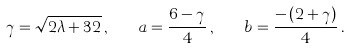<formula> <loc_0><loc_0><loc_500><loc_500>\gamma = \sqrt { 2 \lambda + 3 2 } \, , \quad a = \frac { 6 - \gamma } { 4 } \, , \quad b = \frac { - \, ( 2 + \gamma ) } { 4 } \, .</formula> 